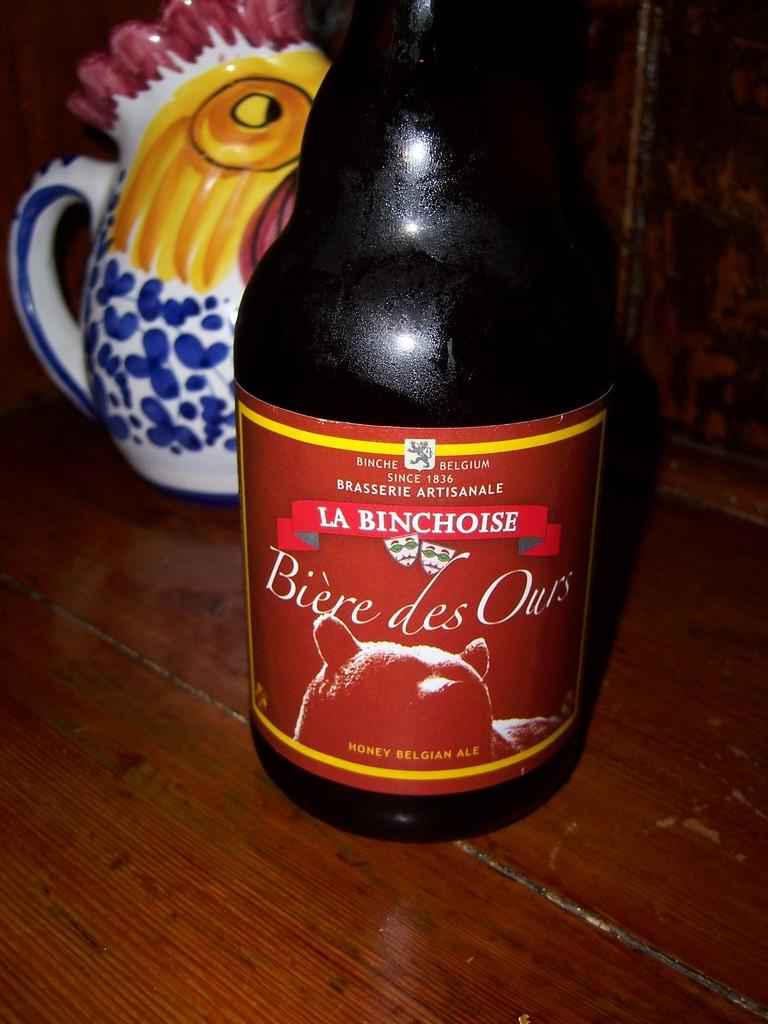What is the main object in the image? There is a bottle in the image. Where is the bottle located? The bottle is placed on a wooden object. What other objects can be seen in the image? There is a colorful mug visible in the image. How many teeth can be seen in the image? There are no teeth visible in the image. Are there any bikes or family members present in the image? There is no mention of bikes or family members in the provided facts, so we cannot determine their presence in the image. 